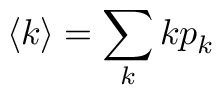Convert formula to latex. <formula><loc_0><loc_0><loc_500><loc_500>\langle k \rangle = \sum _ { k } k p _ { k }</formula> 